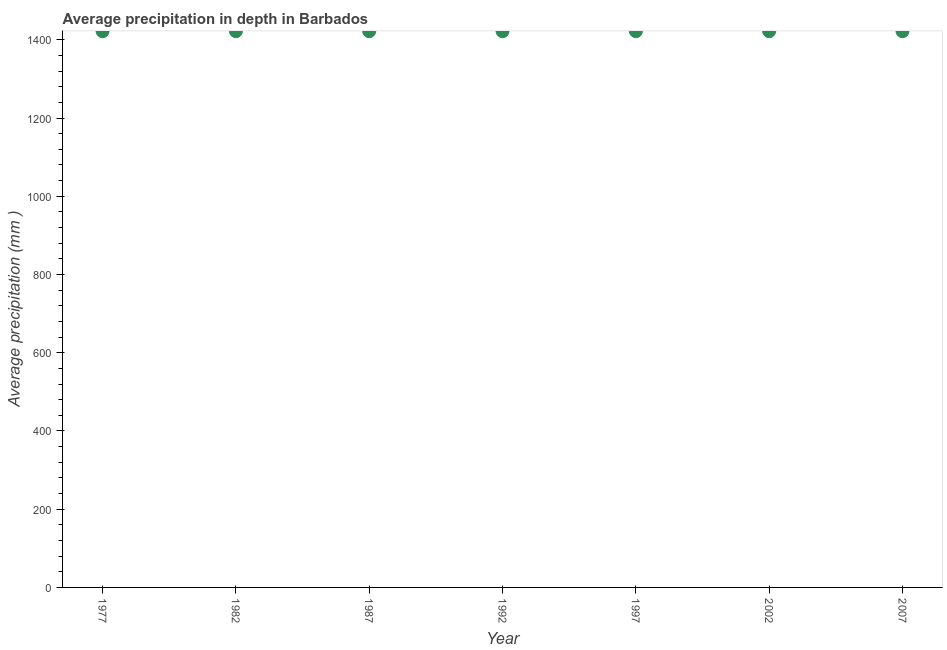What is the average precipitation in depth in 1997?
Your answer should be very brief. 1422. Across all years, what is the maximum average precipitation in depth?
Your answer should be compact. 1422. Across all years, what is the minimum average precipitation in depth?
Provide a succinct answer. 1422. In which year was the average precipitation in depth maximum?
Provide a short and direct response. 1977. In which year was the average precipitation in depth minimum?
Offer a terse response. 1977. What is the sum of the average precipitation in depth?
Ensure brevity in your answer.  9954. What is the average average precipitation in depth per year?
Ensure brevity in your answer.  1422. What is the median average precipitation in depth?
Provide a short and direct response. 1422. Is the average precipitation in depth in 1977 less than that in 2007?
Give a very brief answer. No. Is the sum of the average precipitation in depth in 1977 and 2007 greater than the maximum average precipitation in depth across all years?
Your response must be concise. Yes. How many dotlines are there?
Ensure brevity in your answer.  1. How many years are there in the graph?
Keep it short and to the point. 7. What is the difference between two consecutive major ticks on the Y-axis?
Keep it short and to the point. 200. Does the graph contain grids?
Your answer should be very brief. No. What is the title of the graph?
Make the answer very short. Average precipitation in depth in Barbados. What is the label or title of the X-axis?
Offer a very short reply. Year. What is the label or title of the Y-axis?
Your answer should be very brief. Average precipitation (mm ). What is the Average precipitation (mm ) in 1977?
Your answer should be compact. 1422. What is the Average precipitation (mm ) in 1982?
Your answer should be very brief. 1422. What is the Average precipitation (mm ) in 1987?
Your response must be concise. 1422. What is the Average precipitation (mm ) in 1992?
Offer a very short reply. 1422. What is the Average precipitation (mm ) in 1997?
Provide a succinct answer. 1422. What is the Average precipitation (mm ) in 2002?
Your answer should be compact. 1422. What is the Average precipitation (mm ) in 2007?
Offer a terse response. 1422. What is the difference between the Average precipitation (mm ) in 1977 and 1992?
Offer a terse response. 0. What is the difference between the Average precipitation (mm ) in 1977 and 1997?
Keep it short and to the point. 0. What is the difference between the Average precipitation (mm ) in 1982 and 1987?
Your answer should be very brief. 0. What is the difference between the Average precipitation (mm ) in 1982 and 1992?
Ensure brevity in your answer.  0. What is the difference between the Average precipitation (mm ) in 1982 and 1997?
Provide a succinct answer. 0. What is the difference between the Average precipitation (mm ) in 1987 and 1992?
Provide a succinct answer. 0. What is the difference between the Average precipitation (mm ) in 1987 and 2007?
Your answer should be compact. 0. What is the difference between the Average precipitation (mm ) in 1992 and 1997?
Provide a succinct answer. 0. What is the difference between the Average precipitation (mm ) in 1992 and 2002?
Offer a very short reply. 0. What is the difference between the Average precipitation (mm ) in 1997 and 2002?
Give a very brief answer. 0. What is the difference between the Average precipitation (mm ) in 1997 and 2007?
Provide a short and direct response. 0. What is the difference between the Average precipitation (mm ) in 2002 and 2007?
Your answer should be very brief. 0. What is the ratio of the Average precipitation (mm ) in 1977 to that in 1982?
Provide a short and direct response. 1. What is the ratio of the Average precipitation (mm ) in 1977 to that in 1997?
Keep it short and to the point. 1. What is the ratio of the Average precipitation (mm ) in 1977 to that in 2007?
Ensure brevity in your answer.  1. What is the ratio of the Average precipitation (mm ) in 1982 to that in 1987?
Offer a very short reply. 1. What is the ratio of the Average precipitation (mm ) in 1982 to that in 1997?
Make the answer very short. 1. What is the ratio of the Average precipitation (mm ) in 1982 to that in 2007?
Your answer should be very brief. 1. What is the ratio of the Average precipitation (mm ) in 1987 to that in 1997?
Your answer should be very brief. 1. What is the ratio of the Average precipitation (mm ) in 1992 to that in 2002?
Your answer should be compact. 1. 